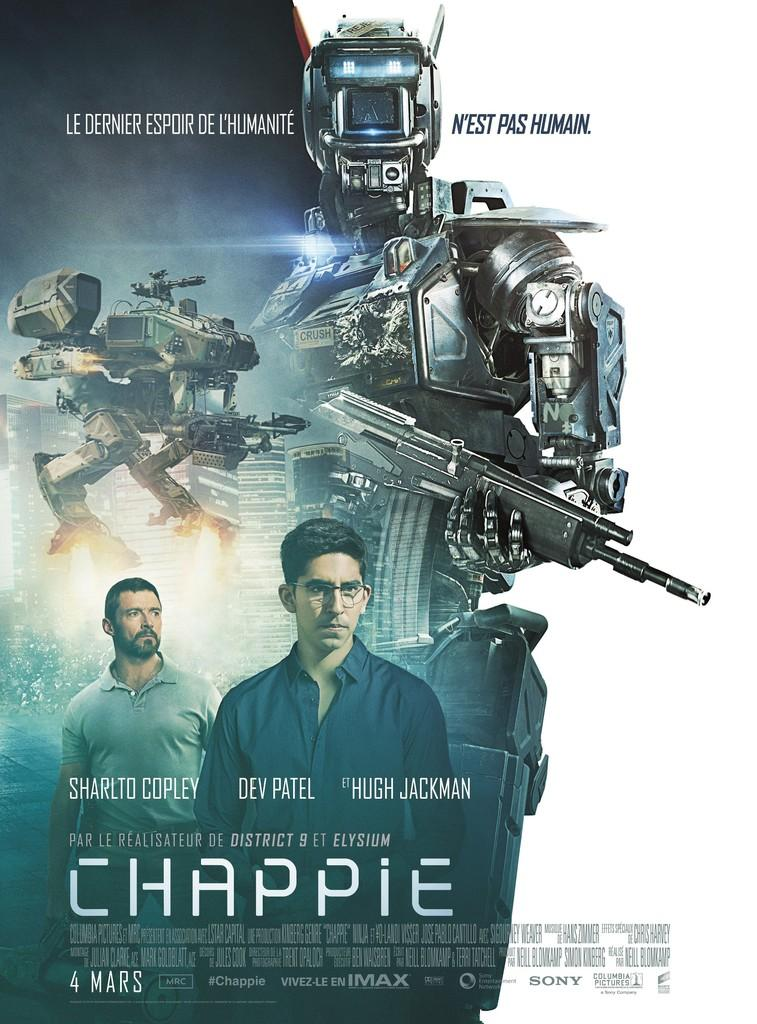<image>
Write a terse but informative summary of the picture. A poster for the Hugh Jackman movie Chappie. 